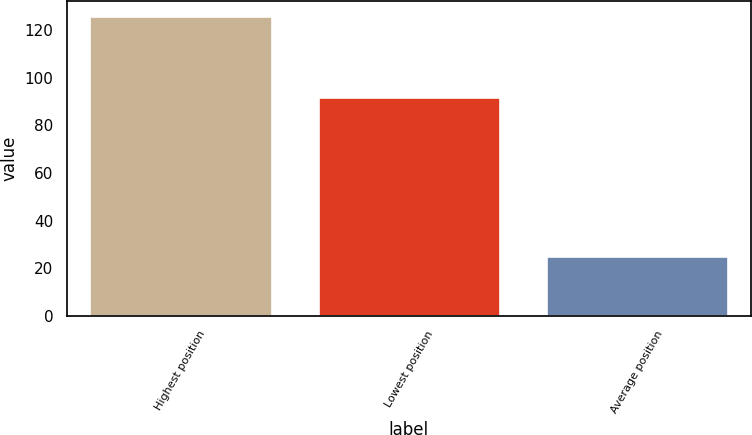<chart> <loc_0><loc_0><loc_500><loc_500><bar_chart><fcel>Highest position<fcel>Lowest position<fcel>Average position<nl><fcel>126<fcel>92<fcel>25<nl></chart> 